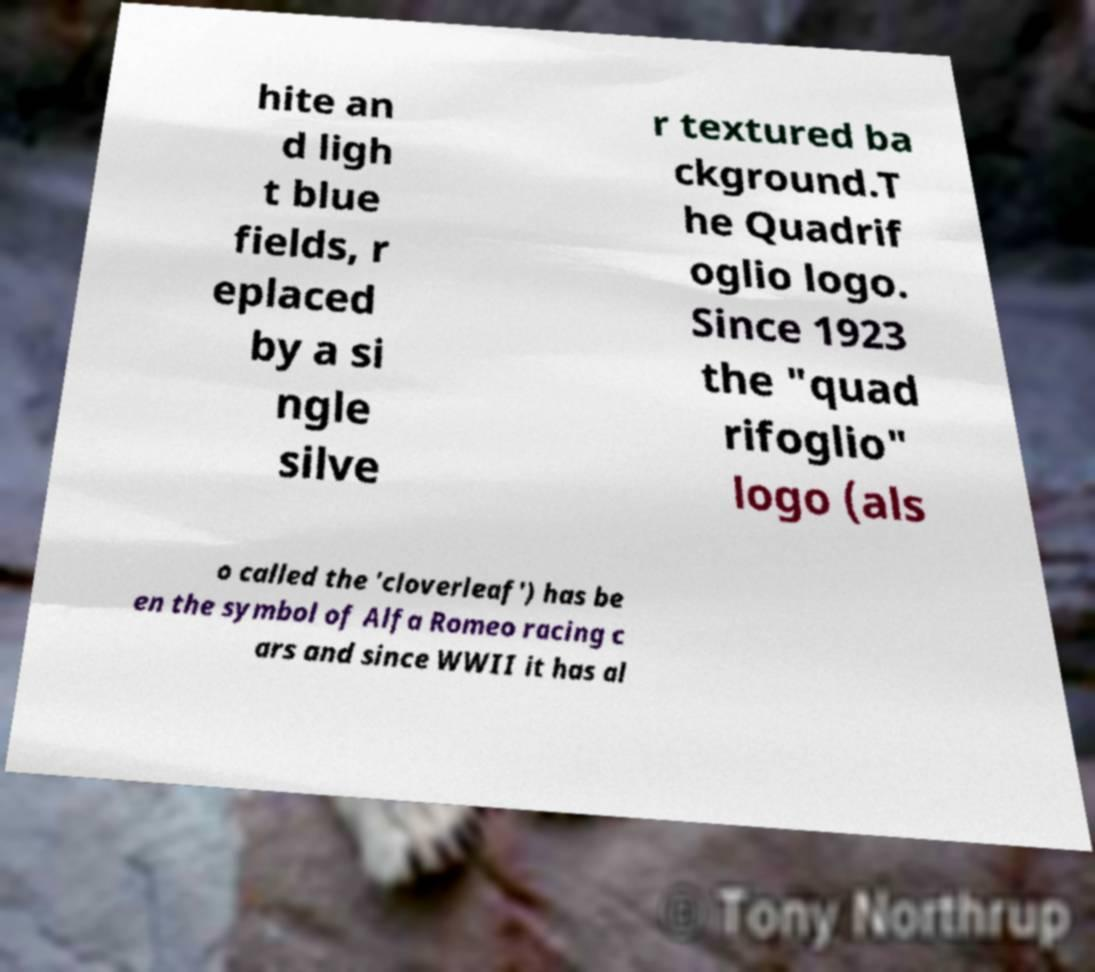Could you extract and type out the text from this image? hite an d ligh t blue fields, r eplaced by a si ngle silve r textured ba ckground.T he Quadrif oglio logo. Since 1923 the "quad rifoglio" logo (als o called the 'cloverleaf') has be en the symbol of Alfa Romeo racing c ars and since WWII it has al 